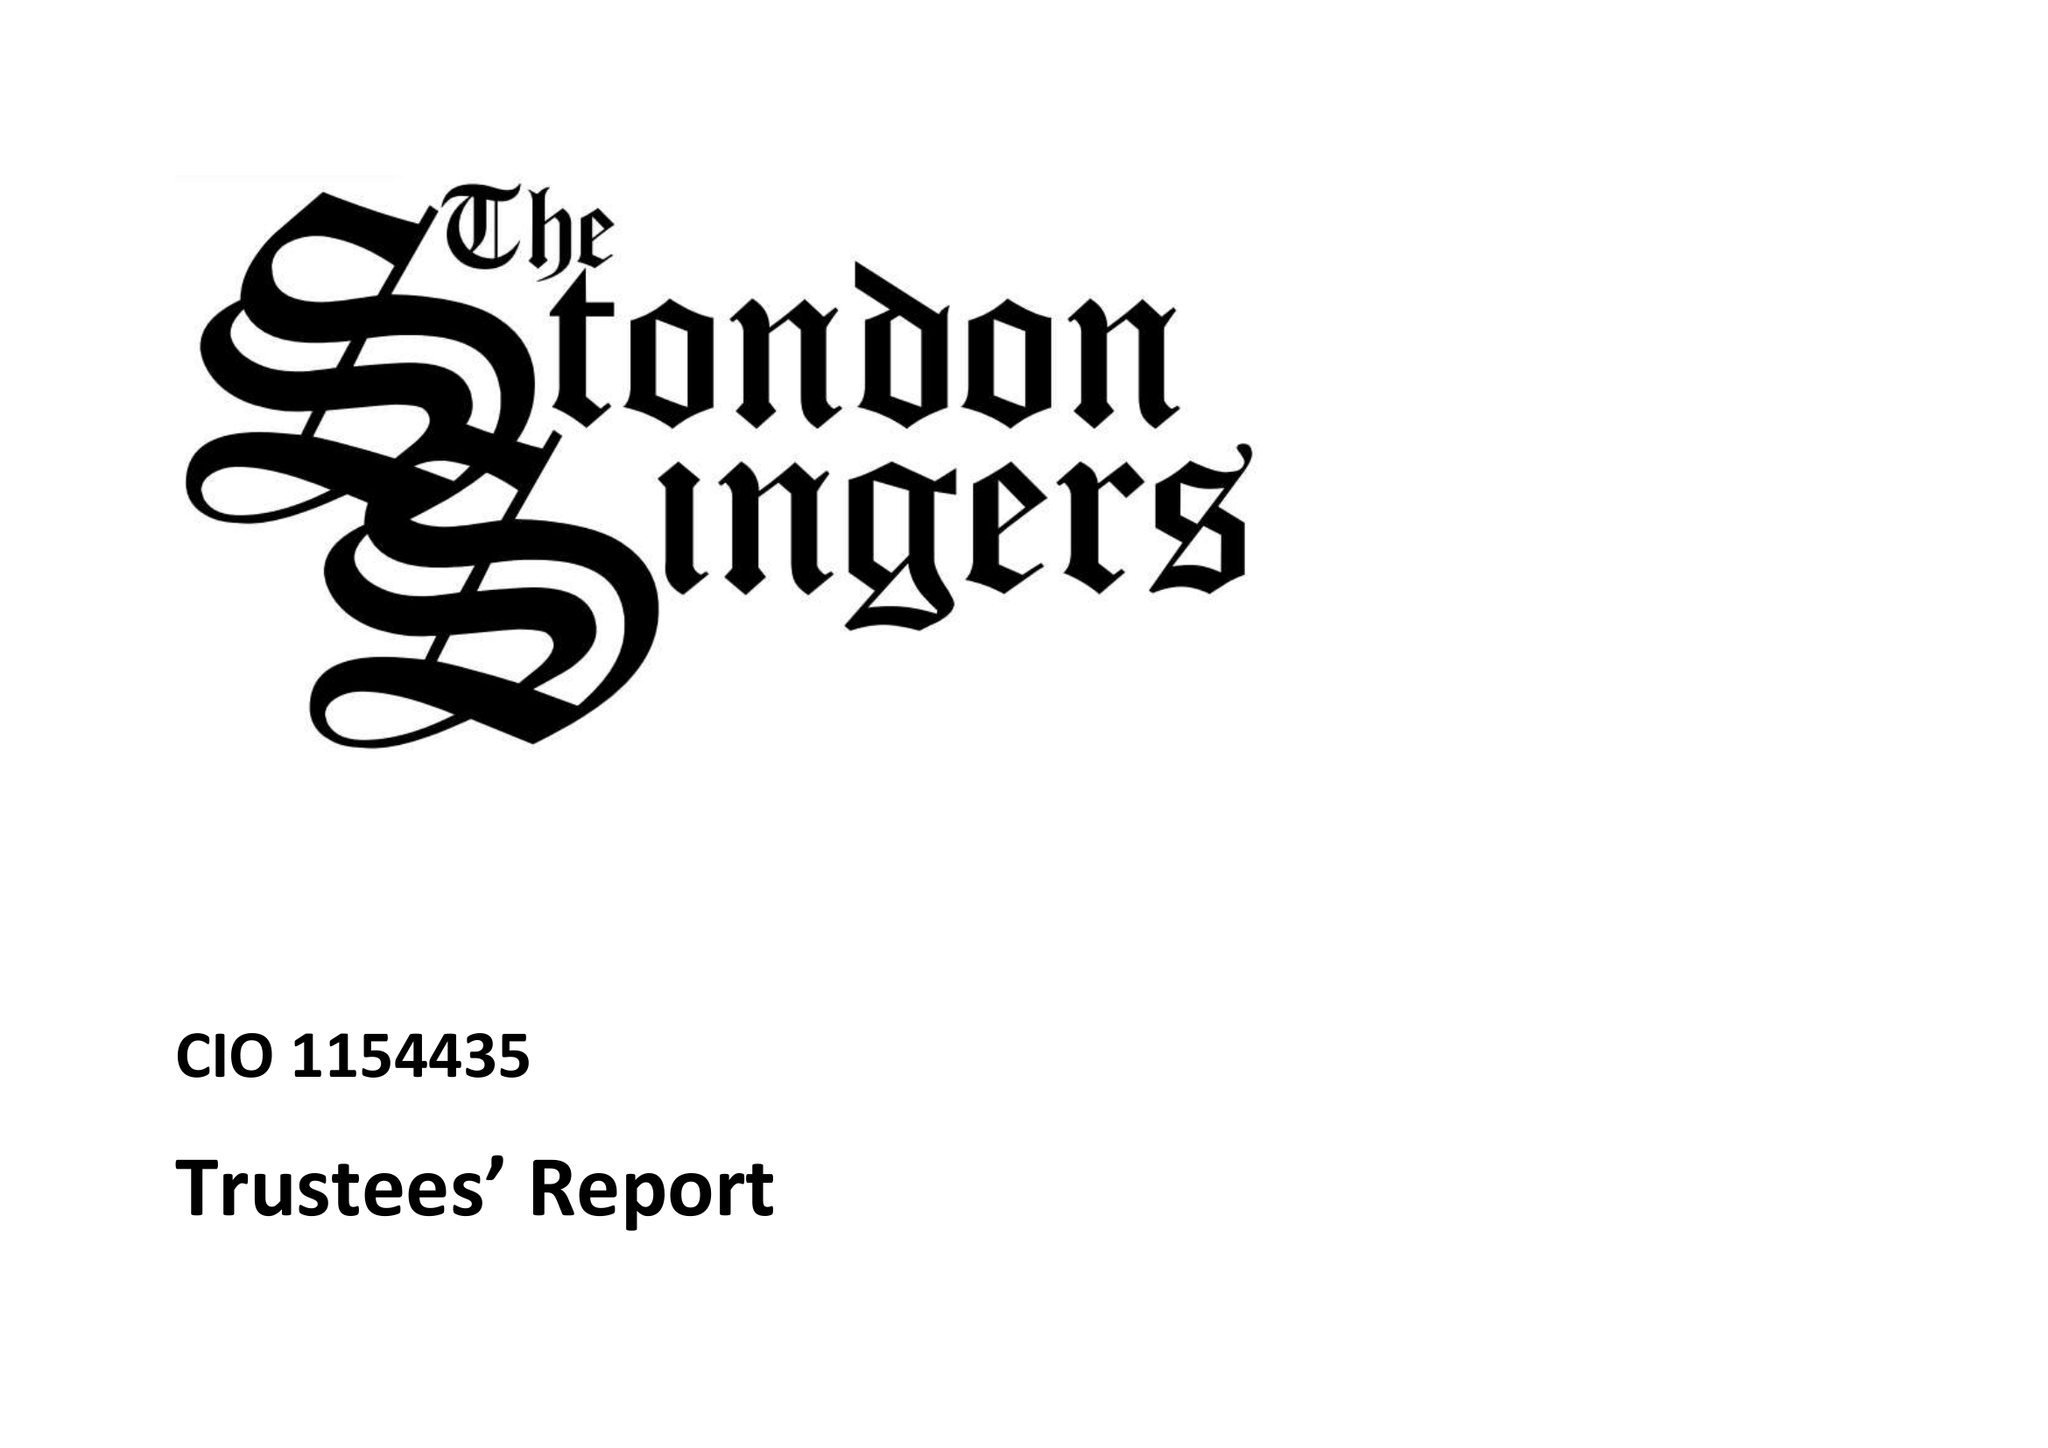What is the value for the income_annually_in_british_pounds?
Answer the question using a single word or phrase. 13002.03 